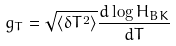<formula> <loc_0><loc_0><loc_500><loc_500>g _ { T } = \sqrt { \left \langle \delta T ^ { 2 } \right \rangle } \frac { d \log H _ { B K } } { d T }</formula> 